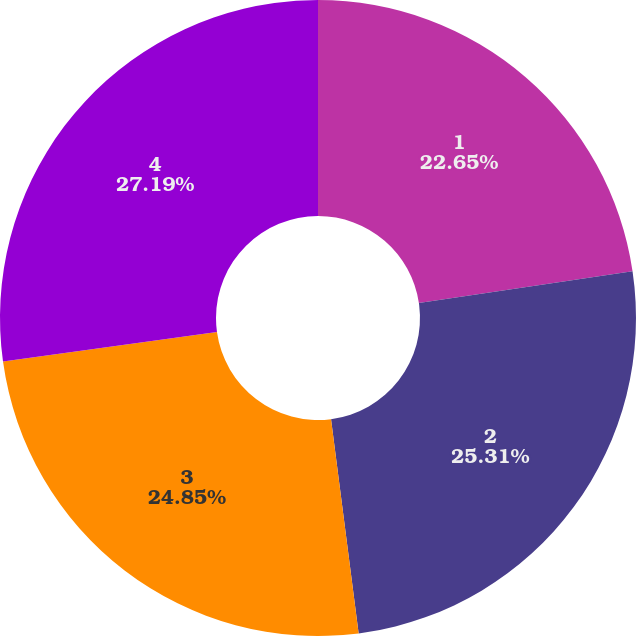Convert chart to OTSL. <chart><loc_0><loc_0><loc_500><loc_500><pie_chart><fcel>1<fcel>2<fcel>3<fcel>4<nl><fcel>22.65%<fcel>25.31%<fcel>24.85%<fcel>27.19%<nl></chart> 